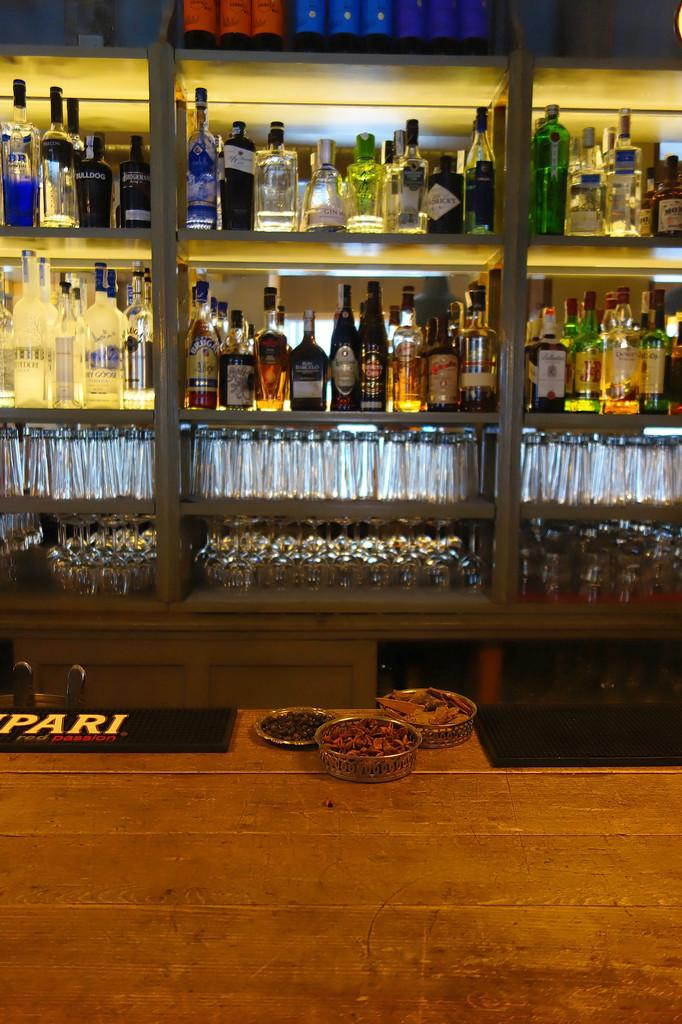What type of bottles are in the image? There are wine bottles in the image. How are the wine bottles arranged in the image? The wine bottles are in racks. What else can be seen in the image besides the wine bottles? There are glasses in the image. Where are the glasses located in the image? The glasses are on the racks. What type of bulb is used to illuminate the wine bottles in the image? There is no bulb present in the image; the image only shows wine bottles and glasses on racks. 